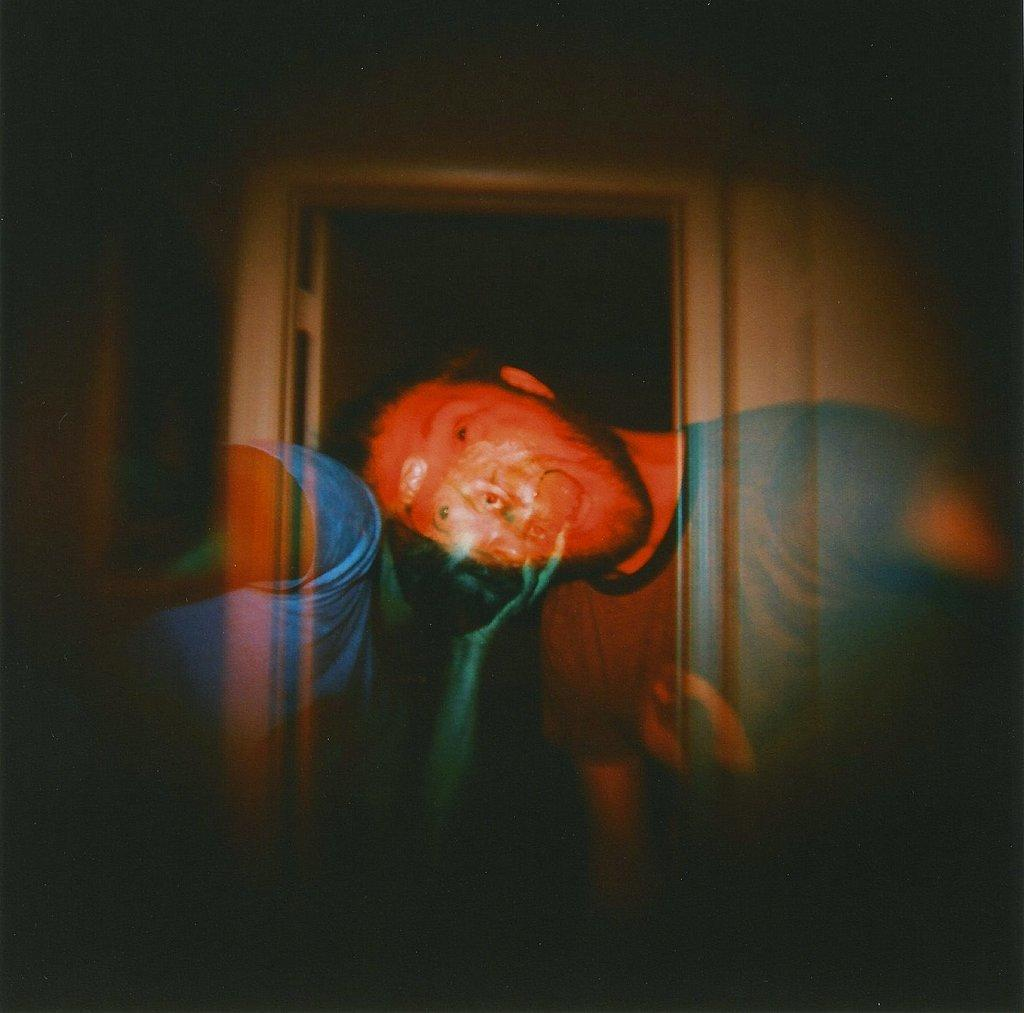How many people are in the image? There are two people standing in the image. What can be inferred about the location based on the image? The image appears to depict an entrance. What chance does the writer have of winning the story competition in the image? There is no writer or story competition present in the image. 